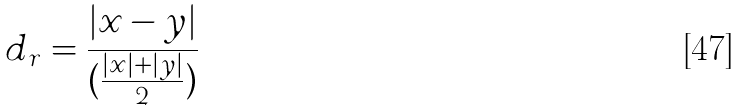<formula> <loc_0><loc_0><loc_500><loc_500>d _ { r } = \frac { | x - y | } { ( \frac { | x | + | y | } { 2 } ) }</formula> 